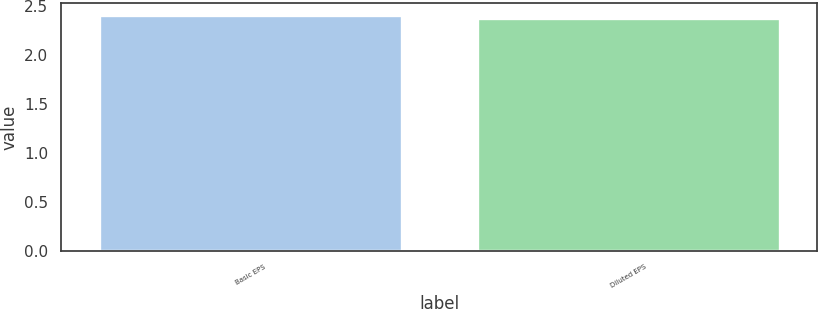<chart> <loc_0><loc_0><loc_500><loc_500><bar_chart><fcel>Basic EPS<fcel>Diluted EPS<nl><fcel>2.41<fcel>2.38<nl></chart> 